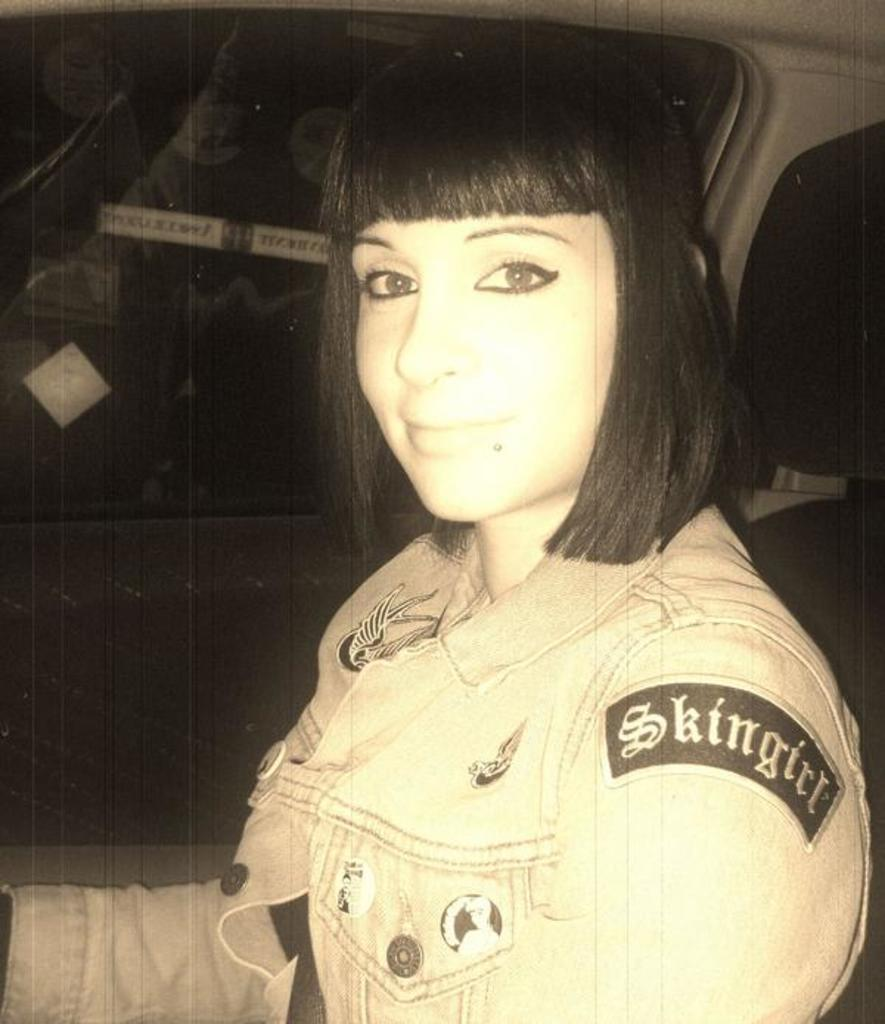What is the girl doing in the image? The girl is sitting inside a vehicle in the image. What is the girl wearing? The girl is wearing a jacket. What can be seen in the background of the image? There is a window visible in the background of the image. Where is the shelf located in the image? There is no shelf present in the image. What type of joke is the girl telling in the image? There is no indication of a joke being told in the image. 